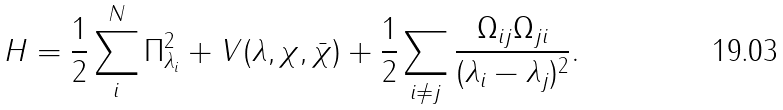Convert formula to latex. <formula><loc_0><loc_0><loc_500><loc_500>H = \frac { 1 } { 2 } \sum _ { i } ^ { N } \Pi _ { \lambda _ { i } } ^ { 2 } + V ( \lambda , \chi , \bar { \chi } ) + \frac { 1 } { 2 } \sum _ { i \neq j } \frac { \Omega _ { i j } \Omega _ { j i } } { ( \lambda _ { i } - \lambda _ { j } ) ^ { 2 } } .</formula> 